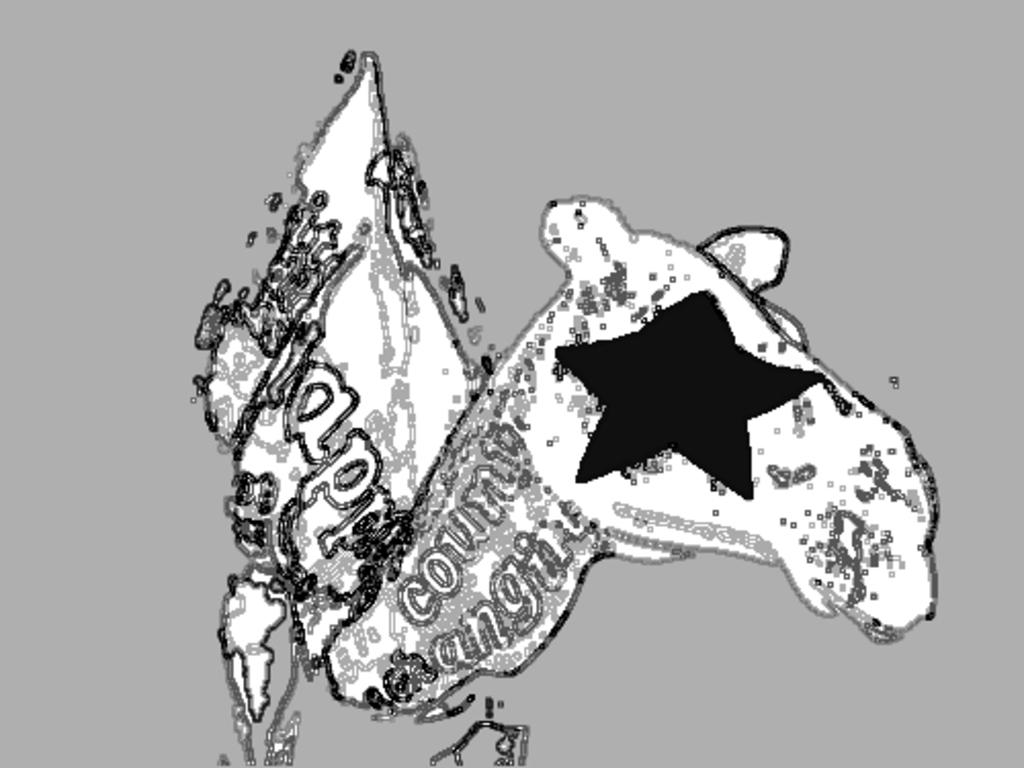What type of picture is the image? The image is an animated picture. What kind of living creature can be seen in the image? There is an animal in the picture. Are there any words or letters in the image? Yes, there is some text in the picture. What type of van is visible in the image? There is no van present in the image. What government policy is being discussed in the image? There is no discussion of government policy in the image. 